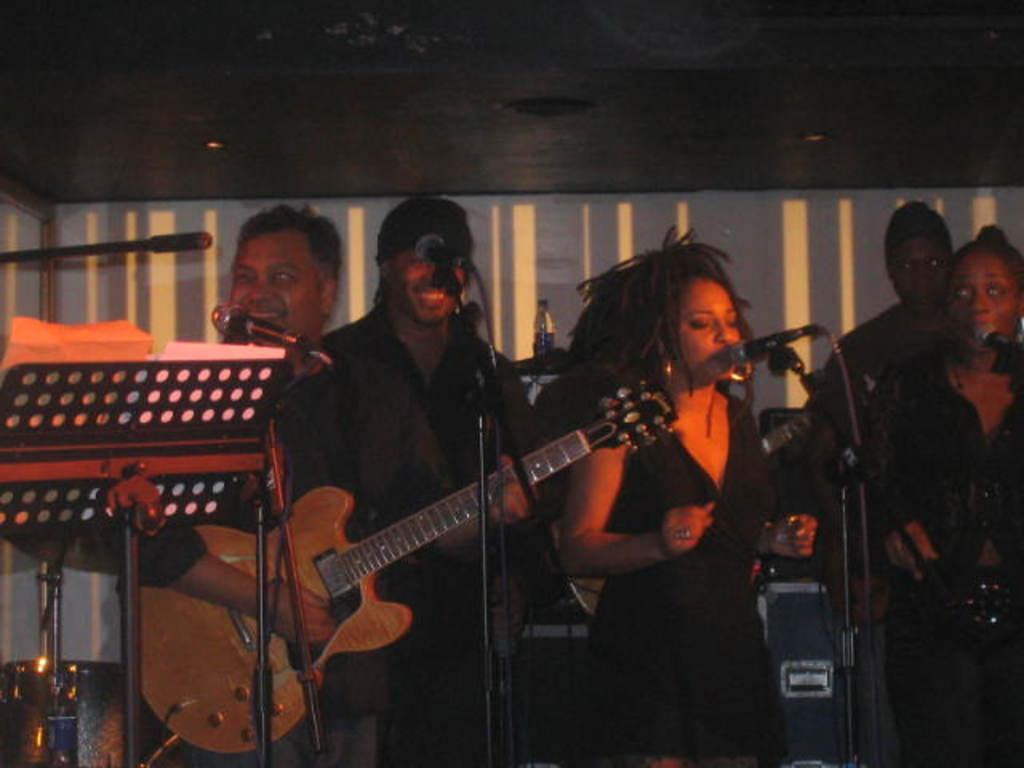Could you give a brief overview of what you see in this image? This 4 musicians are standing and singing in-front of mic. This person is holding a guitar and playing. On this board with pole there are papers. 